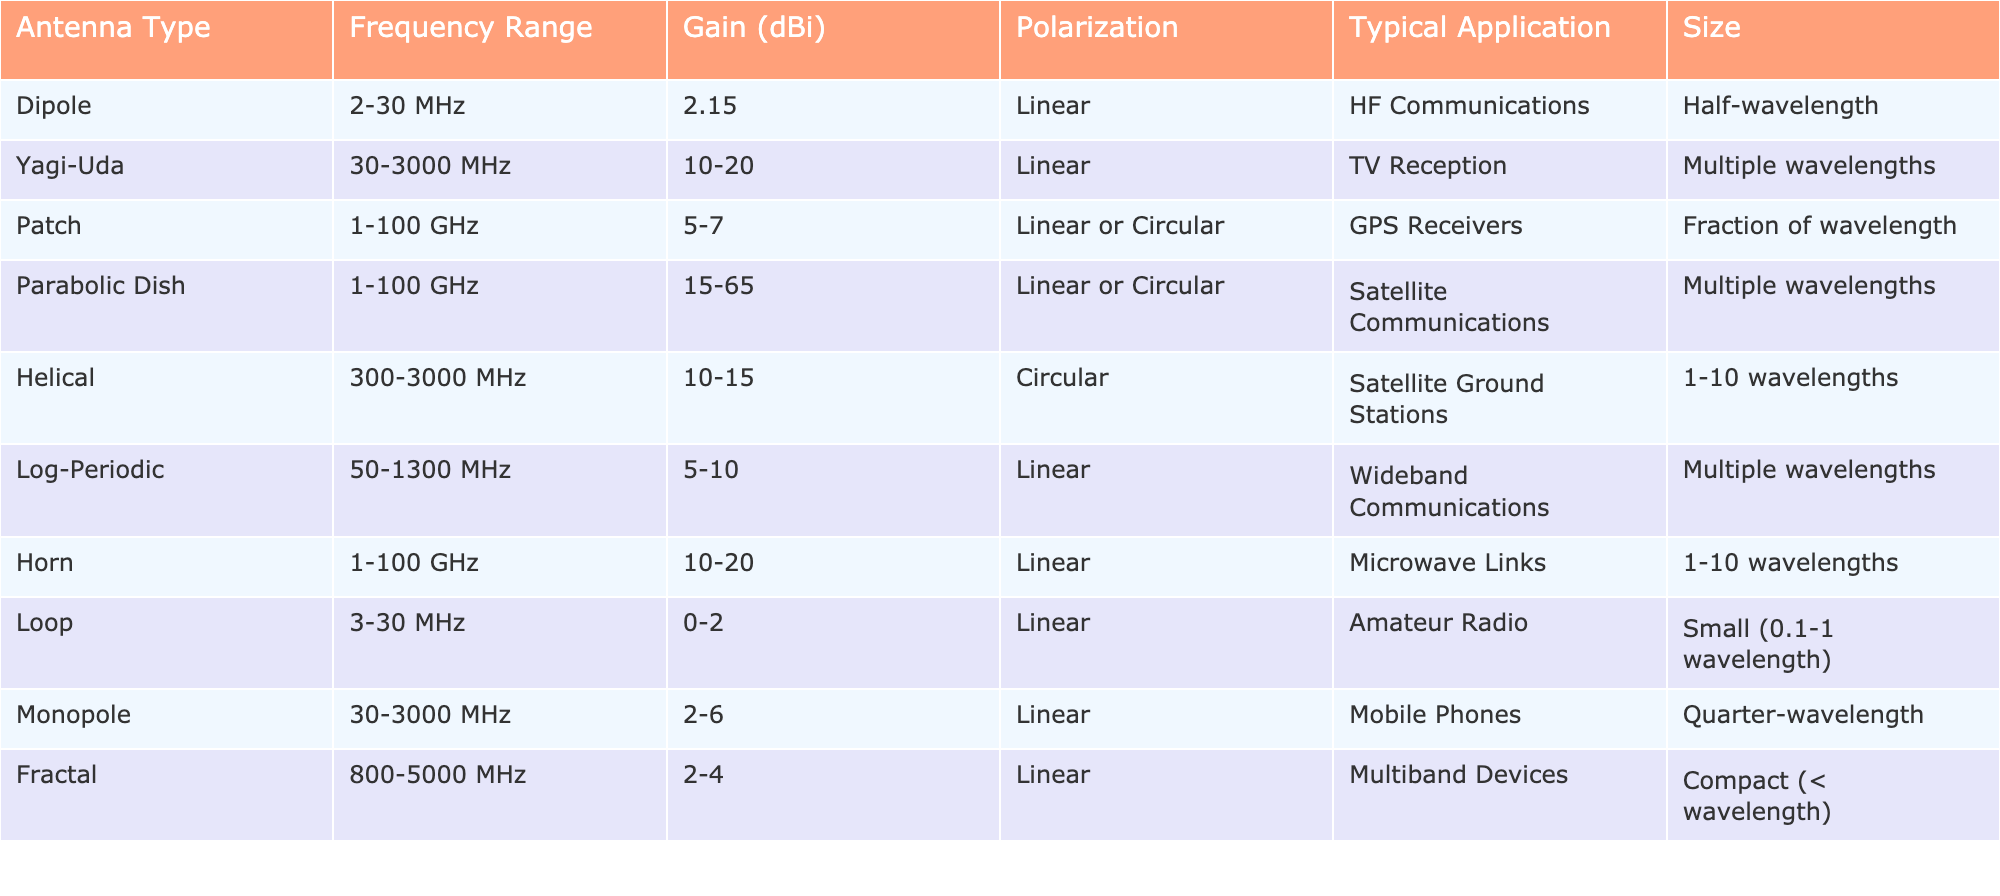What is the frequency range of a Yagi-Uda antenna? The table lists the properties of various antennas. By locating the row for the Yagi-Uda antenna, I can see the frequency range stated in the corresponding column. It shows that the frequency range is 30-3000 MHz.
Answer: 30-3000 MHz Which antenna type has the highest gain? To determine the antenna type with the highest gain, I should review the "Gain (dBi)" column and find the maximum value. The Parabolic Dish has a gain of 15-65 dBi, which is the highest when considering the range.
Answer: Parabolic Dish Is a Loop antenna typically used for satellite communications? By checking the "Typical Application" column for the Loop antenna, it states "Amateur Radio," indicating that it is not used for satellite communications.
Answer: No What is the size of a dipole antenna? The table specifies the size of the Dipole antenna in the "Size" column. It indicates that its size is half-wavelength.
Answer: Half-wavelength What is the average gain of Monopole and Dipole antennas? First, I will locate the gain values for both Monopole (2-6 dBi) and Dipole (2.15 dBi). To find the average, I take the midpoint of each range (4 dBi for Monopole and 2.15 dBi for Dipole), sum them (4 + 2.15 = 6.15), and divide by 2 which gives 3.075 dBi.
Answer: 3.075 dBi Which antennas have a circular polarization? I will check the "Polarization" column for antennas that specify "Circular." From the table, the Helical and Parabolic Dish antennas fall into this category.
Answer: Helical, Parabolic Dish What is the frequency range of antennas typically used for GPS receivers? To find this, I need to locate the row for the Patch antenna in the "Typical Application" column, which corresponds to GPS Receivers. The frequency range for the Patch antenna is 1-100 GHz.
Answer: 1-100 GHz How many antenna types are designed for wideband communications? By scanning the "Typical Application" column for entries that contain "Wideband Communications," I find that only the Log-Periodic antenna fits this application, resulting in a count of one.
Answer: 1 